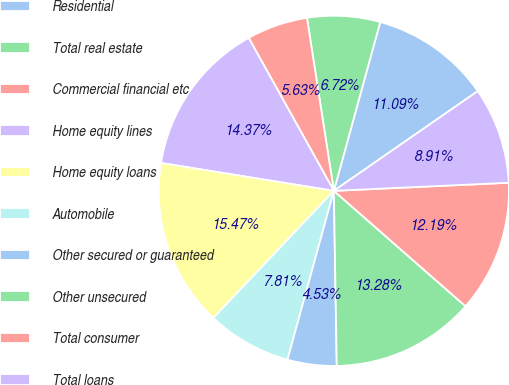Convert chart to OTSL. <chart><loc_0><loc_0><loc_500><loc_500><pie_chart><fcel>Residential<fcel>Total real estate<fcel>Commercial financial etc<fcel>Home equity lines<fcel>Home equity loans<fcel>Automobile<fcel>Other secured or guaranteed<fcel>Other unsecured<fcel>Total consumer<fcel>Total loans<nl><fcel>11.09%<fcel>6.72%<fcel>5.63%<fcel>14.37%<fcel>15.47%<fcel>7.81%<fcel>4.53%<fcel>13.28%<fcel>12.19%<fcel>8.91%<nl></chart> 